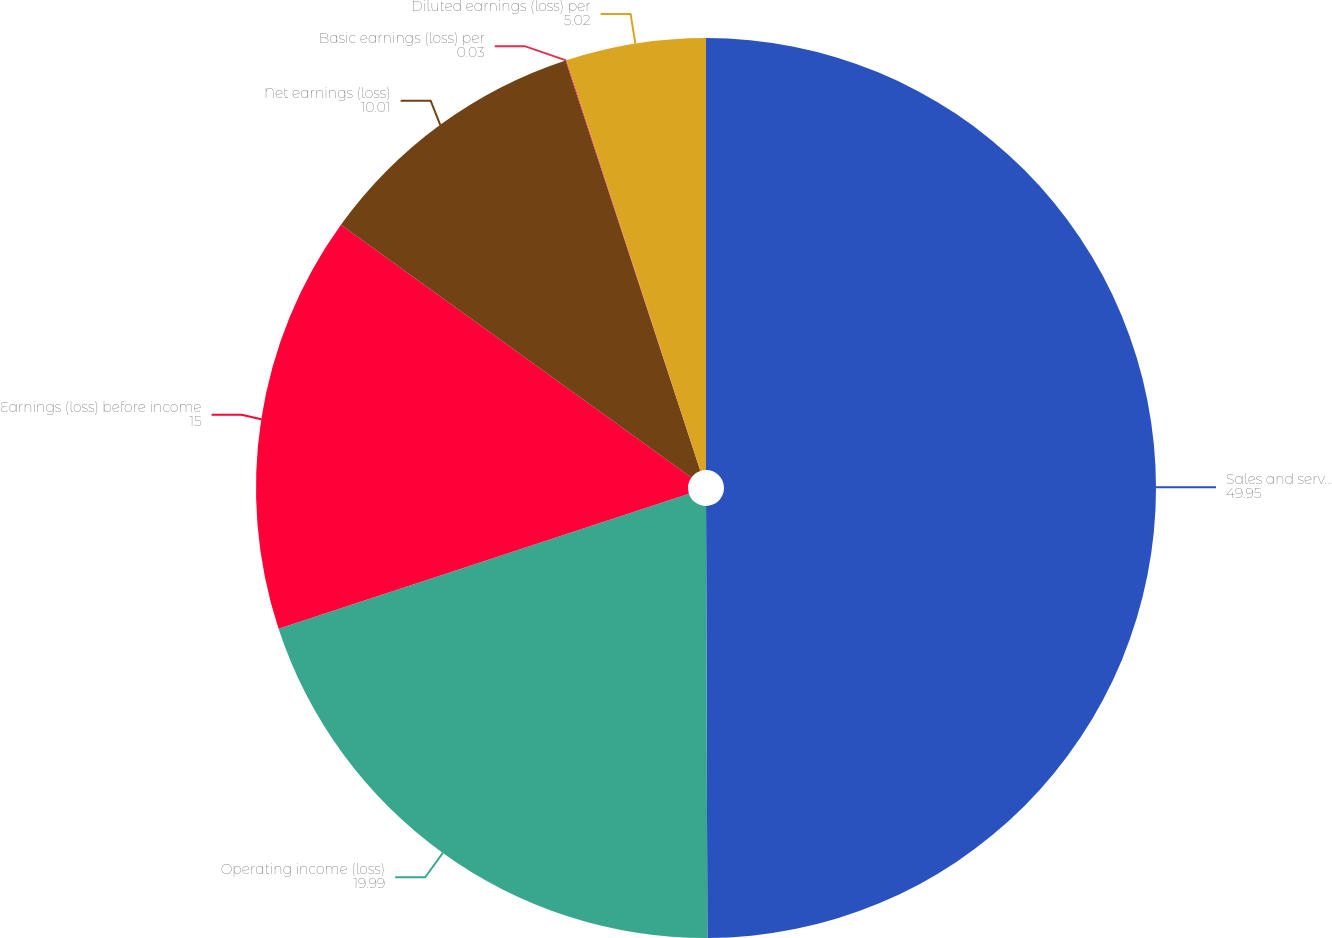Convert chart. <chart><loc_0><loc_0><loc_500><loc_500><pie_chart><fcel>Sales and service revenues<fcel>Operating income (loss)<fcel>Earnings (loss) before income<fcel>Net earnings (loss)<fcel>Basic earnings (loss) per<fcel>Diluted earnings (loss) per<nl><fcel>49.95%<fcel>19.99%<fcel>15.0%<fcel>10.01%<fcel>0.03%<fcel>5.02%<nl></chart> 